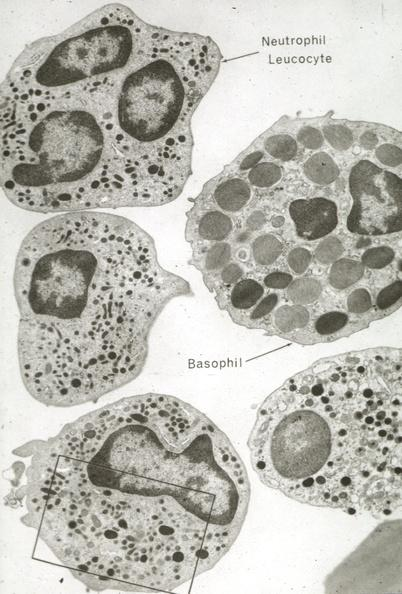what does this image show?
Answer the question using a single word or phrase. Neutrophils and basophil 